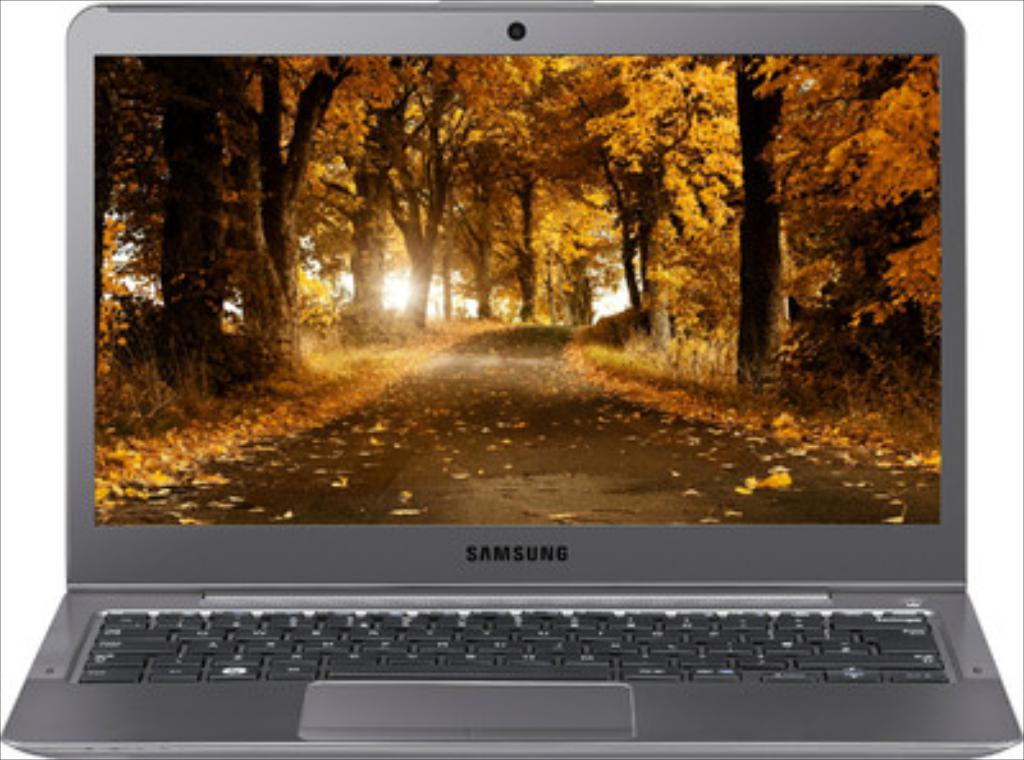<image>
Describe the image concisely. A grey Samsung laptop with a screen showing orange Fall leaves. 